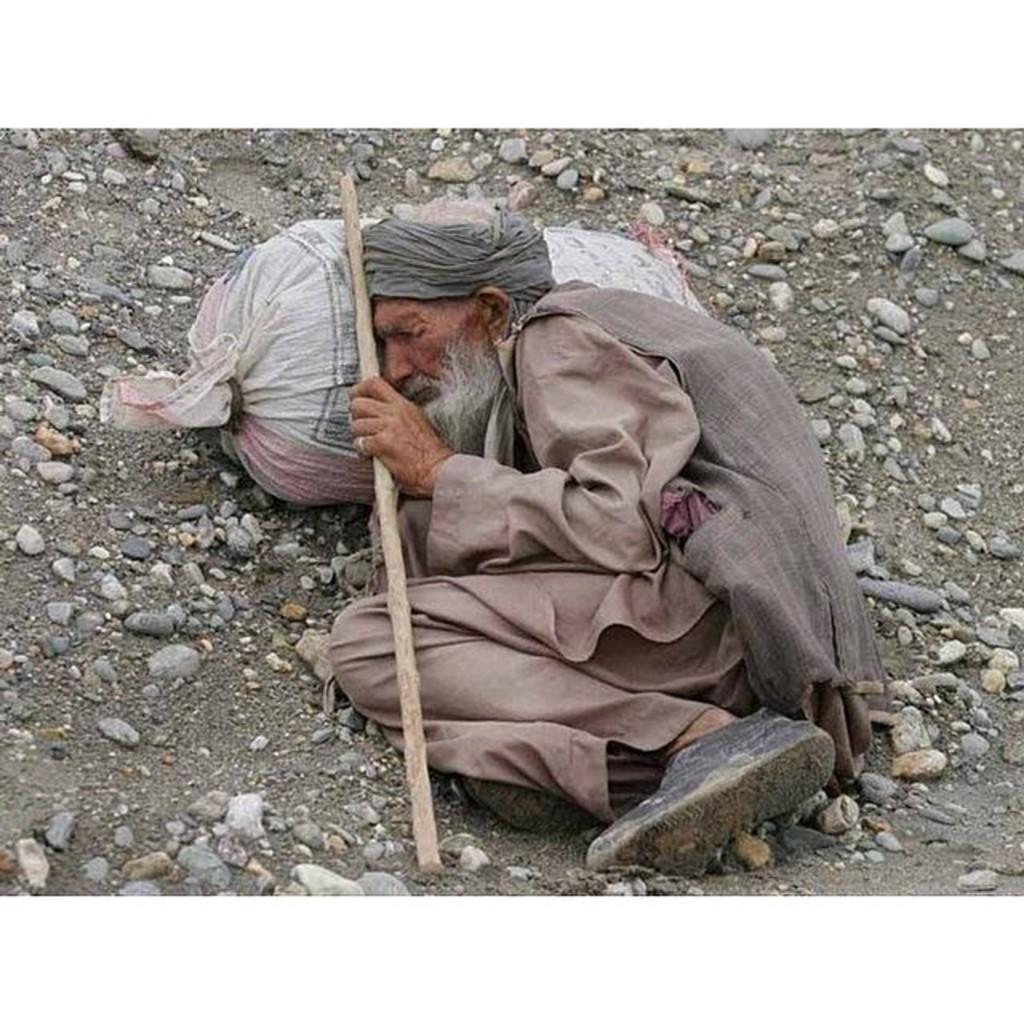Who is the main subject in the image? There is an old man in the image. What is the old man doing in the image? The old man is laying on the ground. What is the old man holding in his hand? The old man is holding a stick in his hand. What else can be seen on the ground in the image? There is a box visible on the ground and small stones are visible on the ground. What type of spoon is the old man using to play the guitar in the image? There is no guitar or spoon present in the image; the old man is holding a stick. 